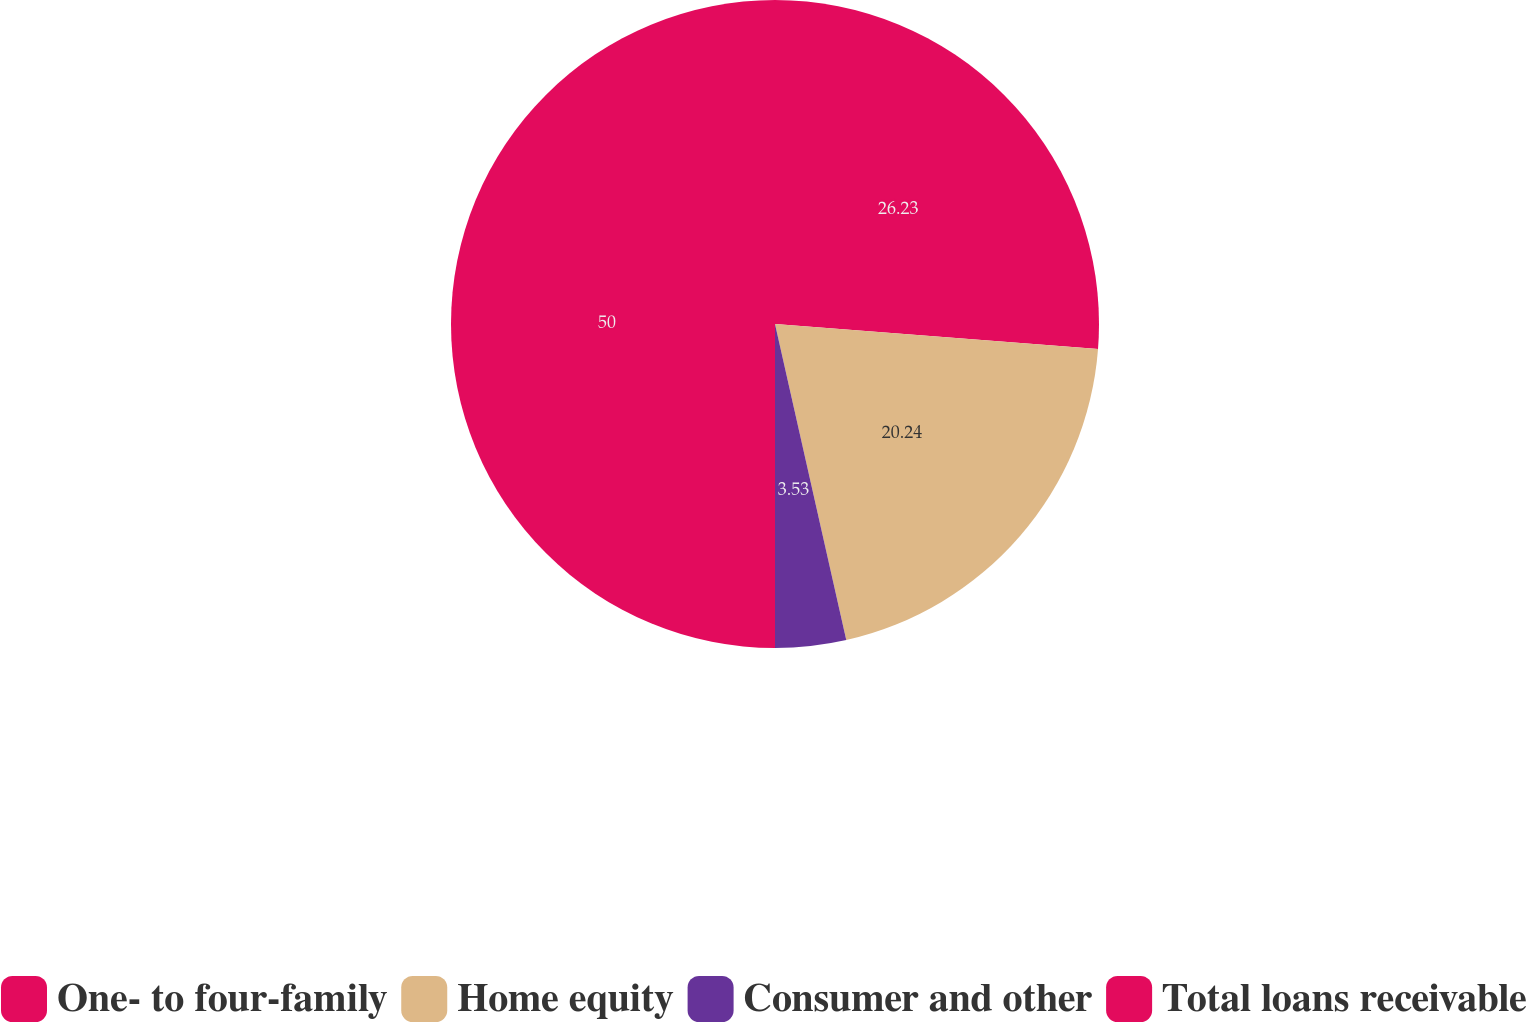Convert chart to OTSL. <chart><loc_0><loc_0><loc_500><loc_500><pie_chart><fcel>One- to four-family<fcel>Home equity<fcel>Consumer and other<fcel>Total loans receivable<nl><fcel>26.23%<fcel>20.24%<fcel>3.53%<fcel>50.0%<nl></chart> 